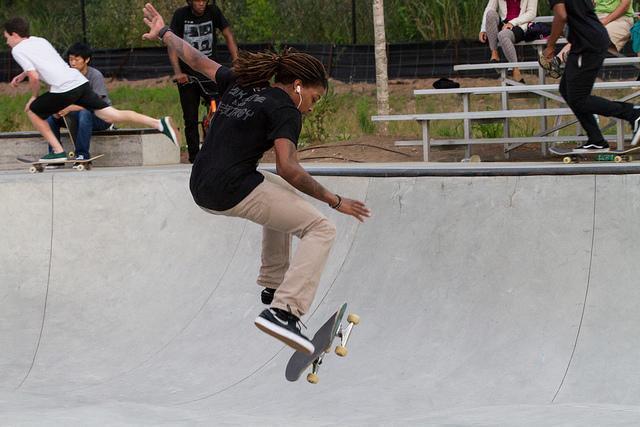What's the name of this type of skating area?
Select the accurate answer and provide explanation: 'Answer: answer
Rationale: rationale.'
Options: Pipe, grid, ramp, bowl. Answer: bowl.
Rationale: The person is in a skate bowl. 